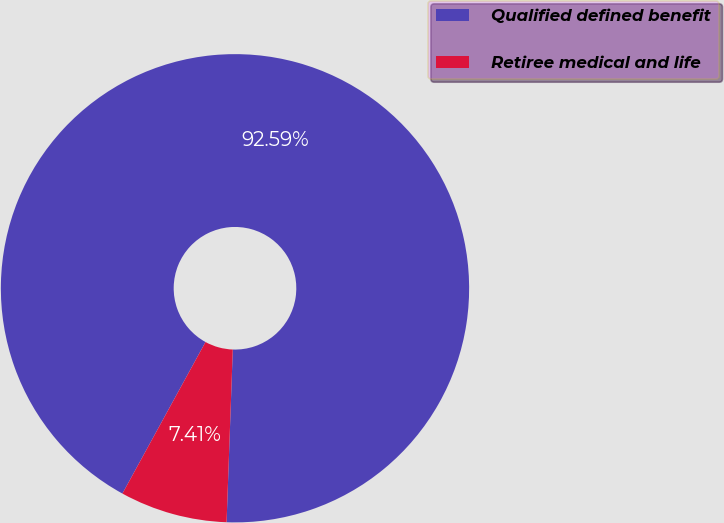Convert chart. <chart><loc_0><loc_0><loc_500><loc_500><pie_chart><fcel>Qualified defined benefit<fcel>Retiree medical and life<nl><fcel>92.59%<fcel>7.41%<nl></chart> 